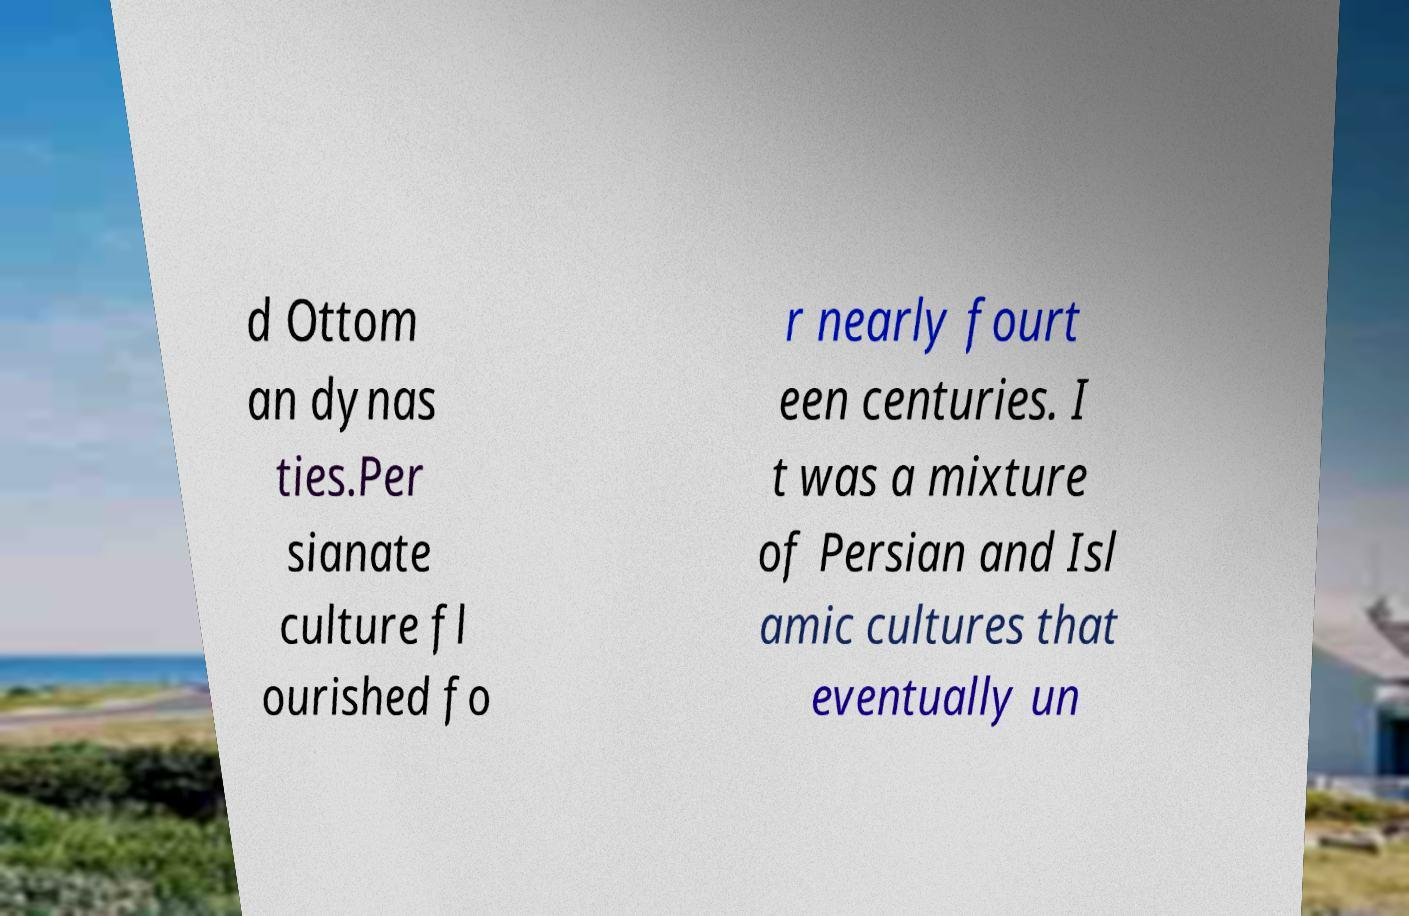What messages or text are displayed in this image? I need them in a readable, typed format. d Ottom an dynas ties.Per sianate culture fl ourished fo r nearly fourt een centuries. I t was a mixture of Persian and Isl amic cultures that eventually un 